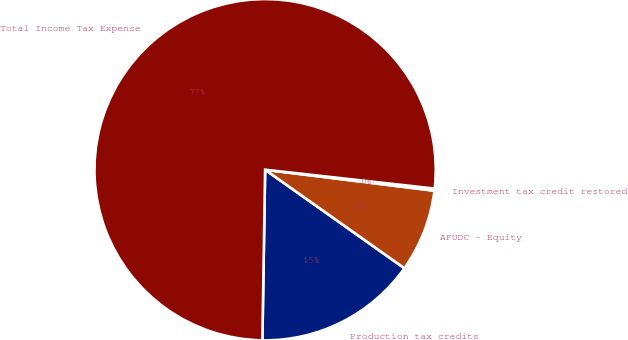<chart> <loc_0><loc_0><loc_500><loc_500><pie_chart><fcel>Production tax credits<fcel>AFUDC - Equity<fcel>Investment tax credit restored<fcel>Total Income Tax Expense<nl><fcel>15.46%<fcel>7.83%<fcel>0.2%<fcel>76.51%<nl></chart> 